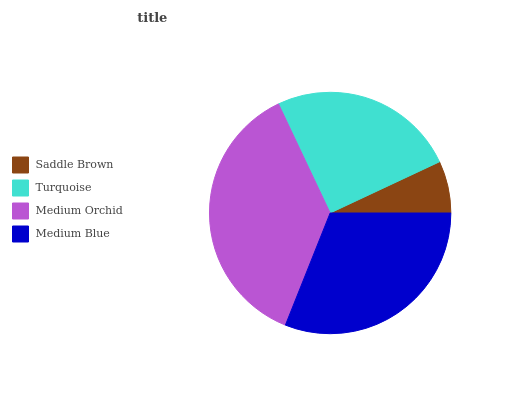Is Saddle Brown the minimum?
Answer yes or no. Yes. Is Medium Orchid the maximum?
Answer yes or no. Yes. Is Turquoise the minimum?
Answer yes or no. No. Is Turquoise the maximum?
Answer yes or no. No. Is Turquoise greater than Saddle Brown?
Answer yes or no. Yes. Is Saddle Brown less than Turquoise?
Answer yes or no. Yes. Is Saddle Brown greater than Turquoise?
Answer yes or no. No. Is Turquoise less than Saddle Brown?
Answer yes or no. No. Is Medium Blue the high median?
Answer yes or no. Yes. Is Turquoise the low median?
Answer yes or no. Yes. Is Turquoise the high median?
Answer yes or no. No. Is Medium Blue the low median?
Answer yes or no. No. 